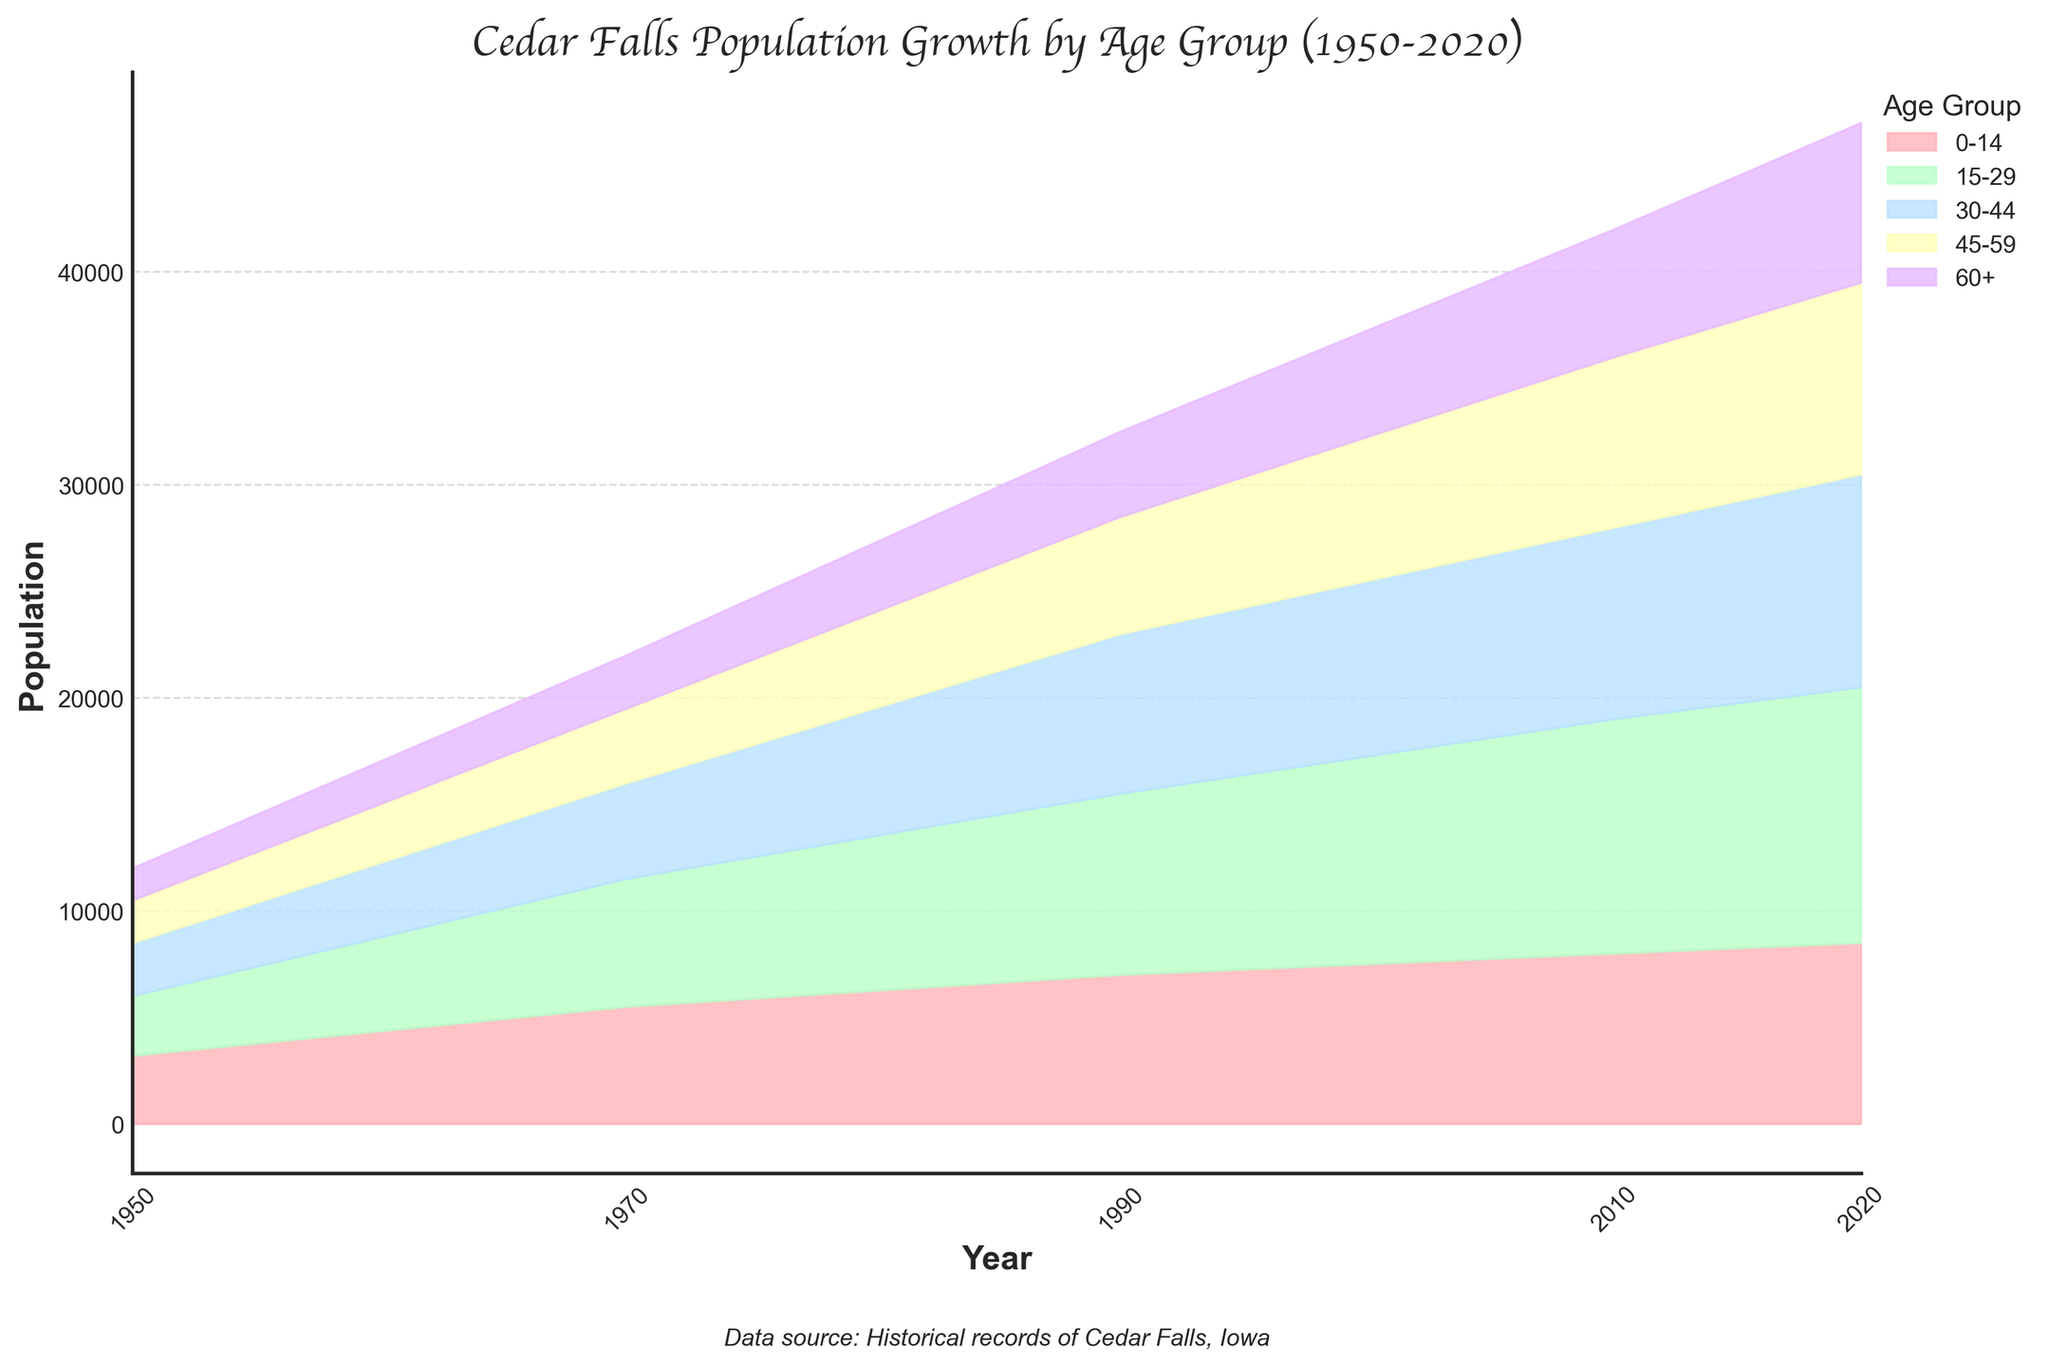When did the youngest age group reach its peak population? To determine this, look at the '0-14' age group's area in the fan chart across different years. The largest area for this group is in 2020.
Answer: 2020 Which age group had the most significant increase in population between 1950 and 2020? Compare the population of each age group between 1950 and 2020. The '15-29' age group increased from 2800 to 12000, which is the highest growth.
Answer: 15-29 What's the total population of Cedar Falls in 2020? Sum the populations for all age groups in 2020. The values are 8500, 12000, 10000, 9000, and 7500. Thus, 8500 + 12000 + 10000 + 9000 + 7500 = 47000
Answer: 47000 Was the population of people aged 60 and above in 2010 more or less than in 1990? Compare the '60+' populations in 2010 and 1990. In 1990, it's 4000, and in 2010, it's 6000. Hence, 6000 > 4000.
Answer: More Which age group saw minimal change in population size from 1950 to 2020? Look at the populations of different age groups in 1950 and 2020. The '0-14' group increased from 3200 to 8500, '15-29' from 2800 to 12000, '30-44' from 2500 to 10000, '45-59' from 2000 to 9000, and '60+' from 1500 to 7500. The '0-14' group saw the least increase.
Answer: 0-14 In which year did the population of the 30-44 age group first exceed 9000? Examine the fan chart for the population of the '30-44' age group across different years. In 2010, the population of this age group first reached 9000.
Answer: 2010 How does the growth trend of the 45-59 age group from 1950 to 2020 compare to that of the 30-44 age group? Compare the population changes from 1950 to 2020 for '45-59' and '30-44' age groups. The '45-59' group increased from 2000 to 9000, and the '30-44' from 2500 to 10000. Both groups show significant growth, but '30-44' has slightly higher growth.
Answer: 30-44 has higher growth What's the average population of the 0-14 age group over the recorded years? Add the population numbers of the '0-14' age group across all years and divide by the number of years: (3200 + 5500 + 7000 + 8000 + 8500) / 5 = 32200 / 5 = 6440
Answer: 6440 Did any age group show a decline in population between any of the recorded decades? Observe the fan chart for each age group across the recorded years. None of the age groups show a population decline between any of the recorded decades.
Answer: No What was the ratio of the population of '15-29' to '60+' in 1990? Divide the population of the '15-29' age group by the '60+' age group in 1990: 8500 / 4000 = 2.125
Answer: 2.125 